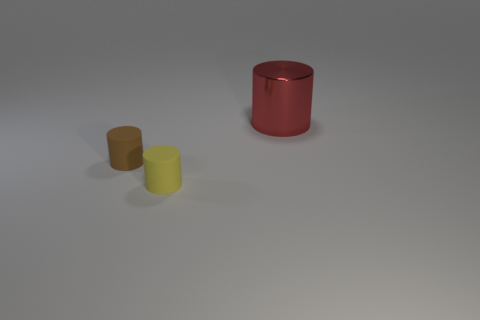Subtract all yellow cylinders. Subtract all red cubes. How many cylinders are left? 2 Add 3 metal objects. How many objects exist? 6 Subtract all brown objects. Subtract all large red matte cylinders. How many objects are left? 2 Add 1 tiny brown matte objects. How many tiny brown matte objects are left? 2 Add 3 blue matte spheres. How many blue matte spheres exist? 3 Subtract 0 green cylinders. How many objects are left? 3 